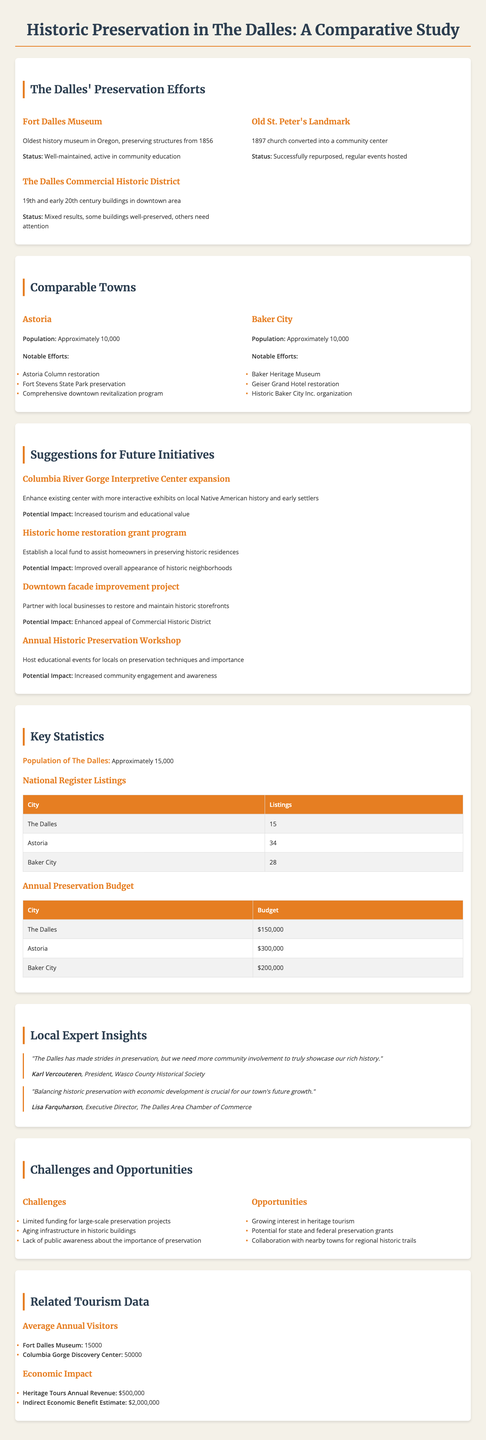What is the oldest history museum in Oregon? The document mentions that Fort Dalles Museum is the oldest history museum in Oregon.
Answer: Fort Dalles Museum How many national register listings does Astoria have? The document provides a table that lists Astoria's national register listings.
Answer: 34 What is the annual preservation budget for Baker City? The document includes a table with annual preservation budgets for various towns, including Baker City.
Answer: $200,000 What potential impact is expected from the expansion of the Columbia River Gorge Interpretive Center? The document states the expected impact from this initiative, highlighting its focus on tourism and education.
Answer: Increased tourism and educational value What are the notable preservation efforts in Baker City? The document lists notable preservation efforts for comparable towns, including Baker City.
Answer: Baker Heritage Museum, Geiser Grand Hotel restoration, Historic Baker City Inc. organization 